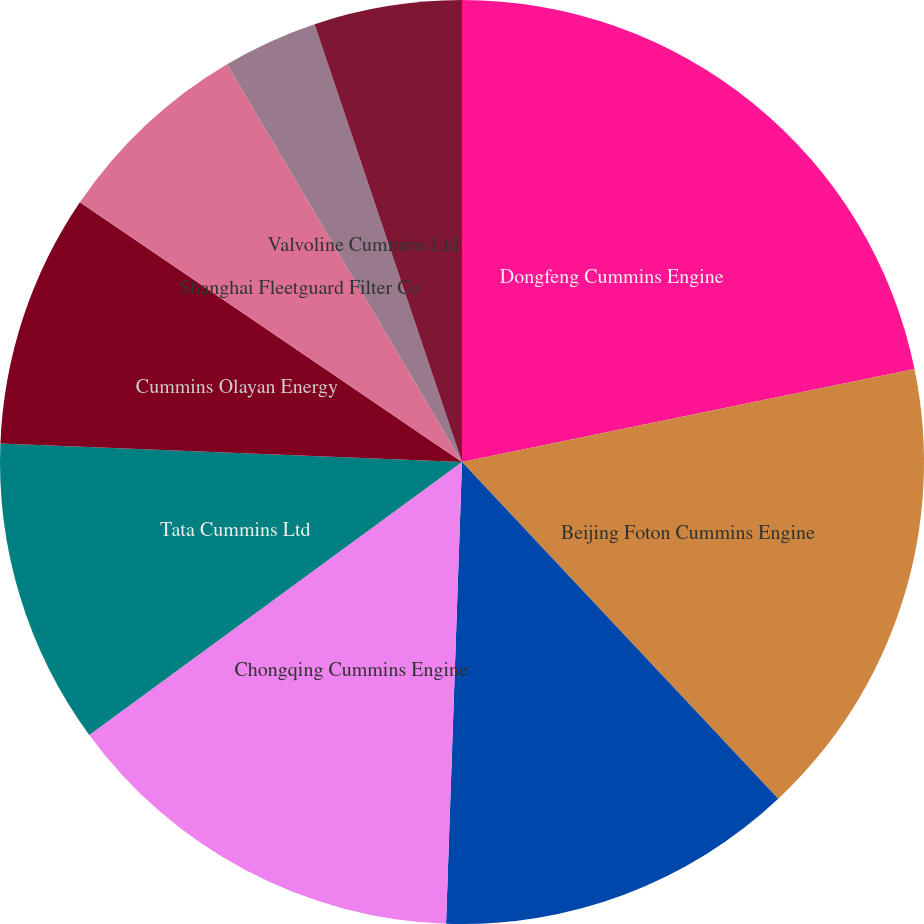<chart> <loc_0><loc_0><loc_500><loc_500><pie_chart><fcel>Dongfeng Cummins Engine<fcel>Beijing Foton Cummins Engine<fcel>Cummins-Scania XPI<fcel>Chongqing Cummins Engine<fcel>Tata Cummins Ltd<fcel>Cummins Olayan Energy<fcel>Shanghai Fleetguard Filter Co<fcel>Valvoline Cummins Ltd<fcel>Fleetguard Filters Private Ltd<nl><fcel>21.77%<fcel>16.23%<fcel>12.55%<fcel>14.39%<fcel>10.7%<fcel>8.86%<fcel>7.01%<fcel>3.32%<fcel>5.17%<nl></chart> 